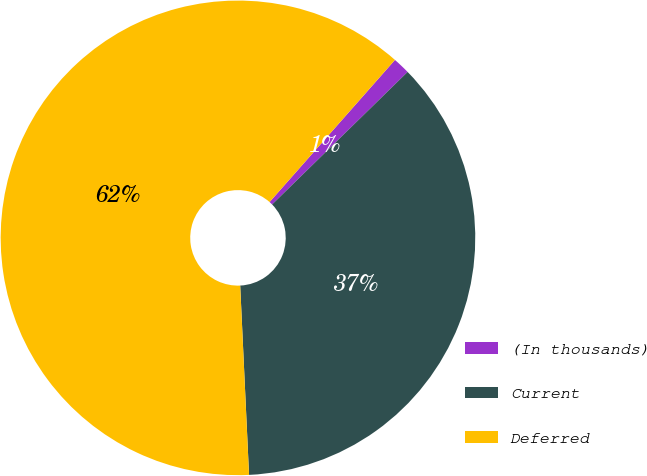Convert chart. <chart><loc_0><loc_0><loc_500><loc_500><pie_chart><fcel>(In thousands)<fcel>Current<fcel>Deferred<nl><fcel>1.17%<fcel>36.58%<fcel>62.25%<nl></chart> 